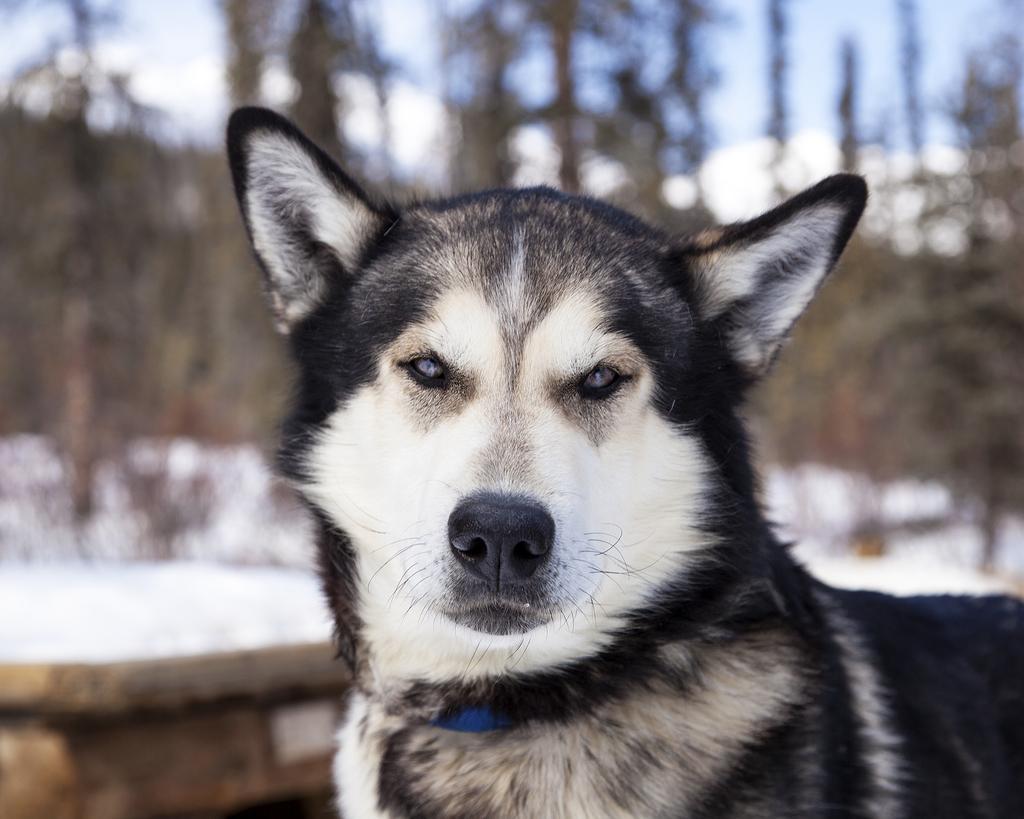Describe this image in one or two sentences. In this image I can see an animal , in the background it might be a tree and the sky. 